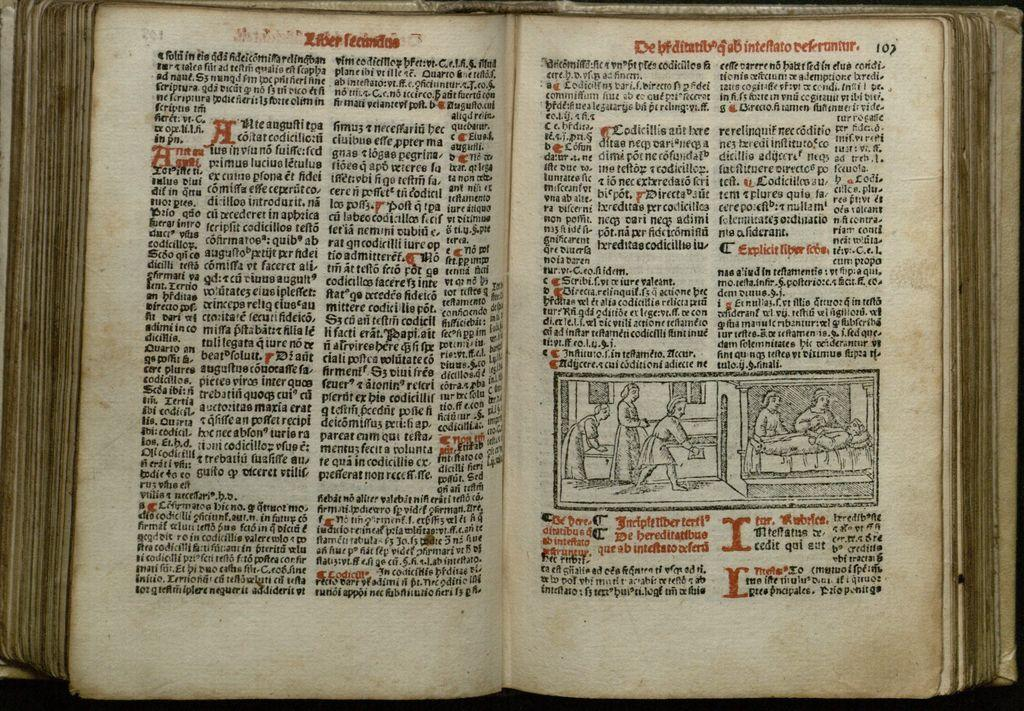Provide a one-sentence caption for the provided image. An open book on a table that is on page 107. 